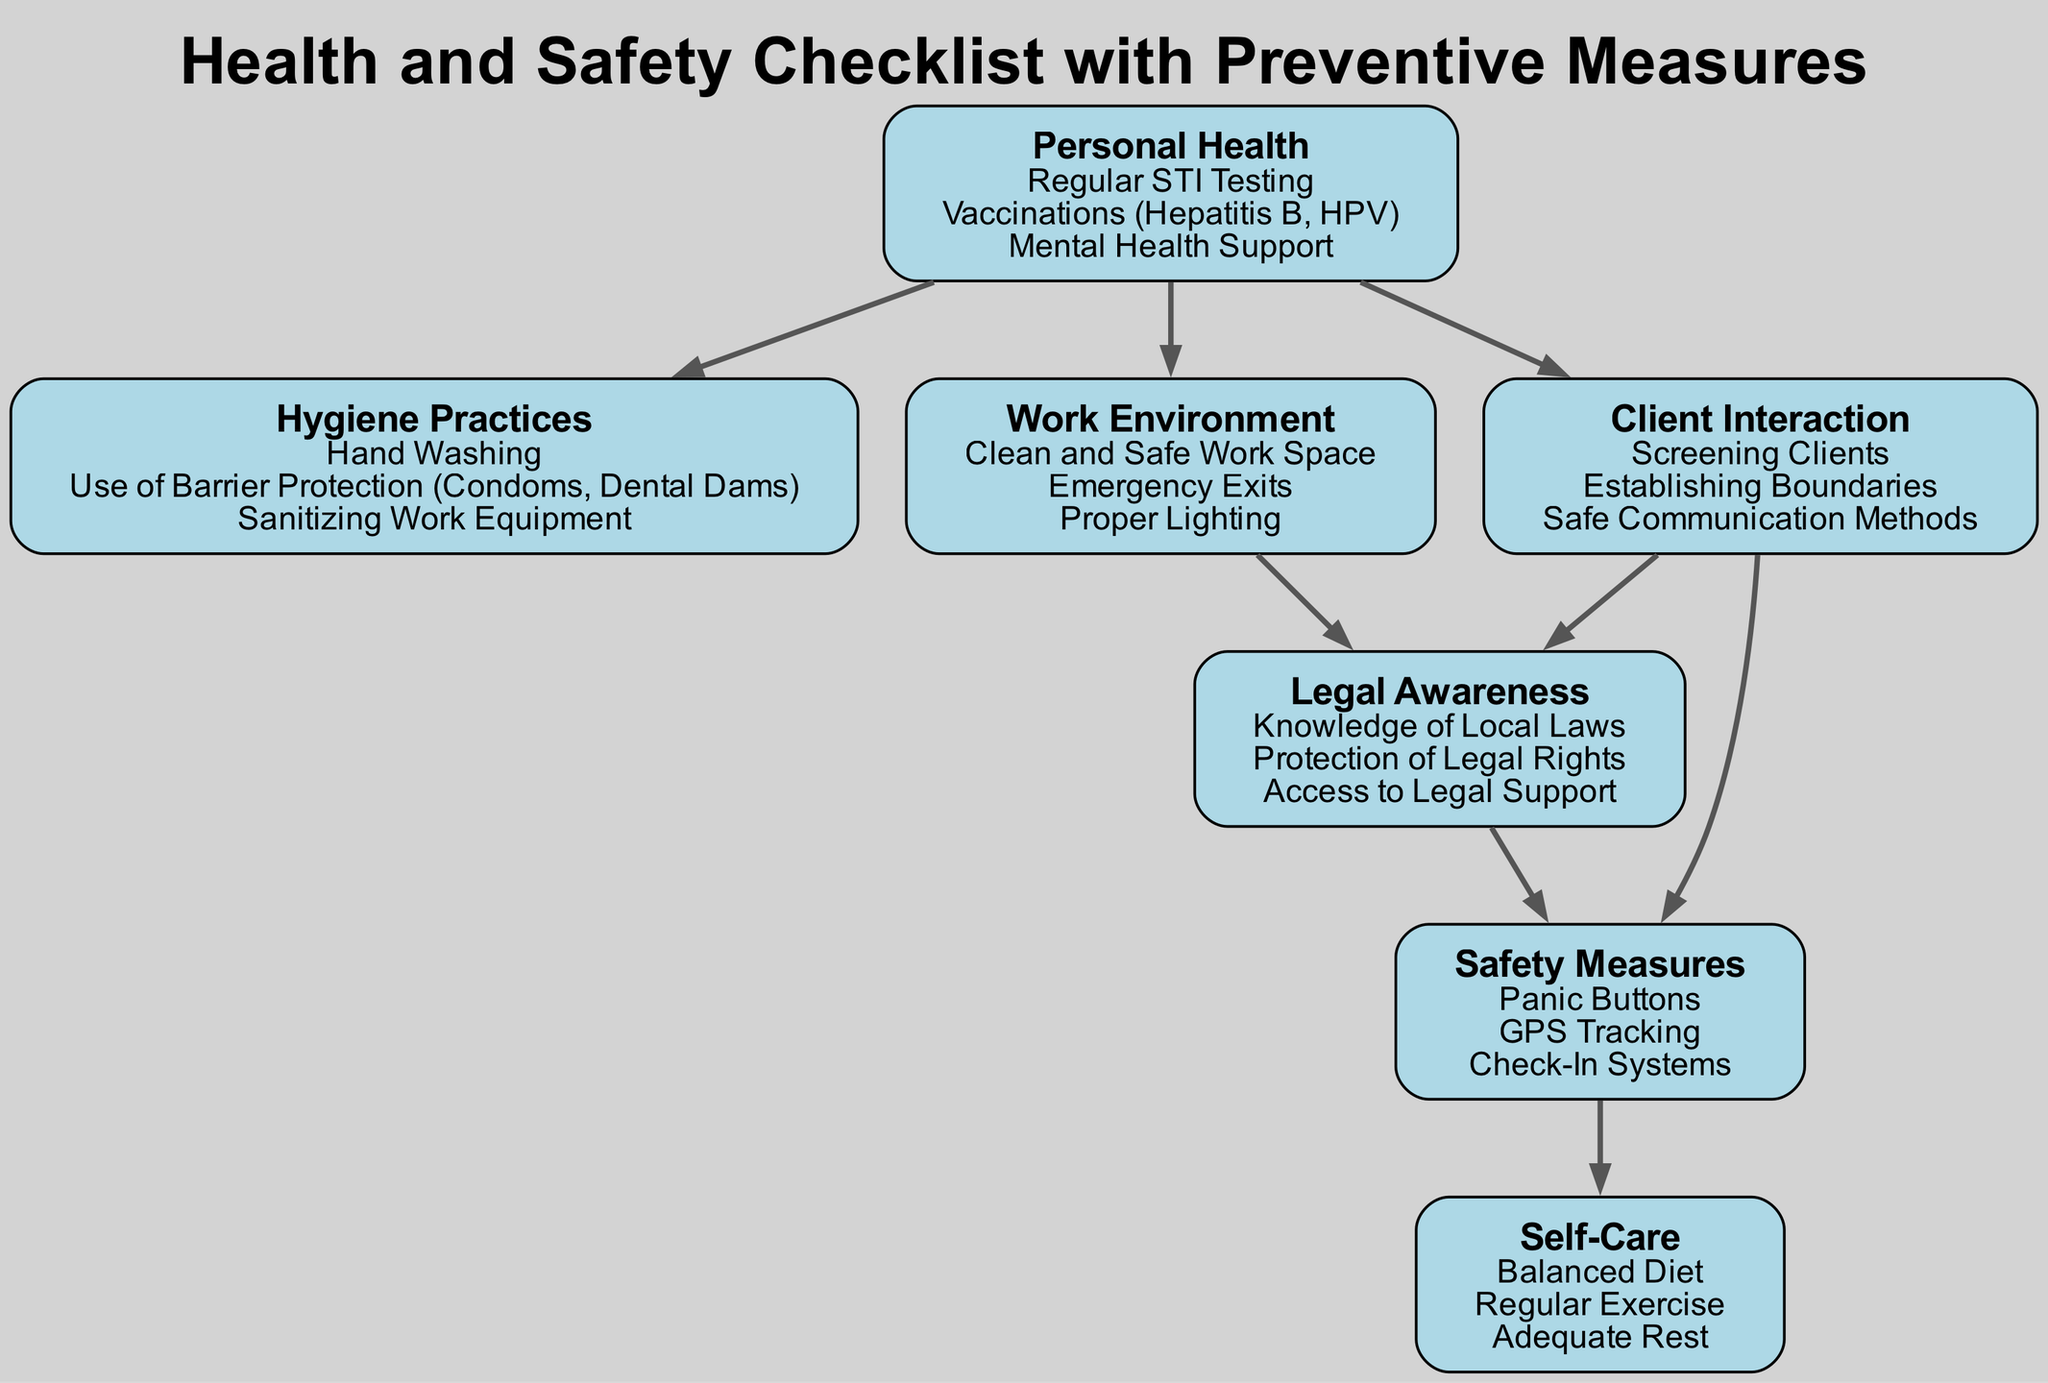What are the three subtopics under Personal Health? The node for Personal Health lists three subtopics: Regular STI Testing, Vaccinations (Hepatitis B, HPV), and Mental Health Support.
Answer: Regular STI Testing, Vaccinations (Hepatitis B, HPV), Mental Health Support How many edges are there in the diagram? Counting the edges listed in the data, there are a total of 8 connections between nodes.
Answer: 8 Which node is directly connected to the Work Environment node? The Work Environment node connects to the Legal Awareness node, as seen in the edges that originate from the Work Environment node.
Answer: Legal Awareness What are the three subtopics of Safety Measures? Looking at the Safety Measures node, the subtopics listed are Panic Buttons, GPS Tracking, and Check-In Systems.
Answer: Panic Buttons, GPS Tracking, Check-In Systems What node connects both the Client Interaction and Safety Measures nodes? The Client Interaction node connects to the Safety Measures node through an edge that signifies an interaction between those two nodes in the diagram.
Answer: Safety Measures How is Personal Health related to Hygiene Practices in the diagram? Personal Health has a direct edge connecting it to Hygiene Practices, indicating the importance of maintaining hygiene as part of personal health.
Answer: Directly connected Which subtopic of Self-Care is suggested at the end of a safety measure? The Safety Measures node connects to the Self-Care node, indicating that the importance of self-care (Adequate Rest) follows from having safety measures in place.
Answer: Adequate Rest Which two nodes are connected by a common edge to Legal Awareness? Both Work Environment and Client Interaction nodes connect to the Legal Awareness node, illustrating its relationship to both areas of focus.
Answer: Work Environment and Client Interaction What is the primary focus of the Hygiene Practices node? Analyzing the subtopics, Hygiene Practices primarily focuses on cleanliness measures such as Hand Washing, Use of Barrier Protection, and Sanitizing Work Equipment.
Answer: Cleanliness measures 